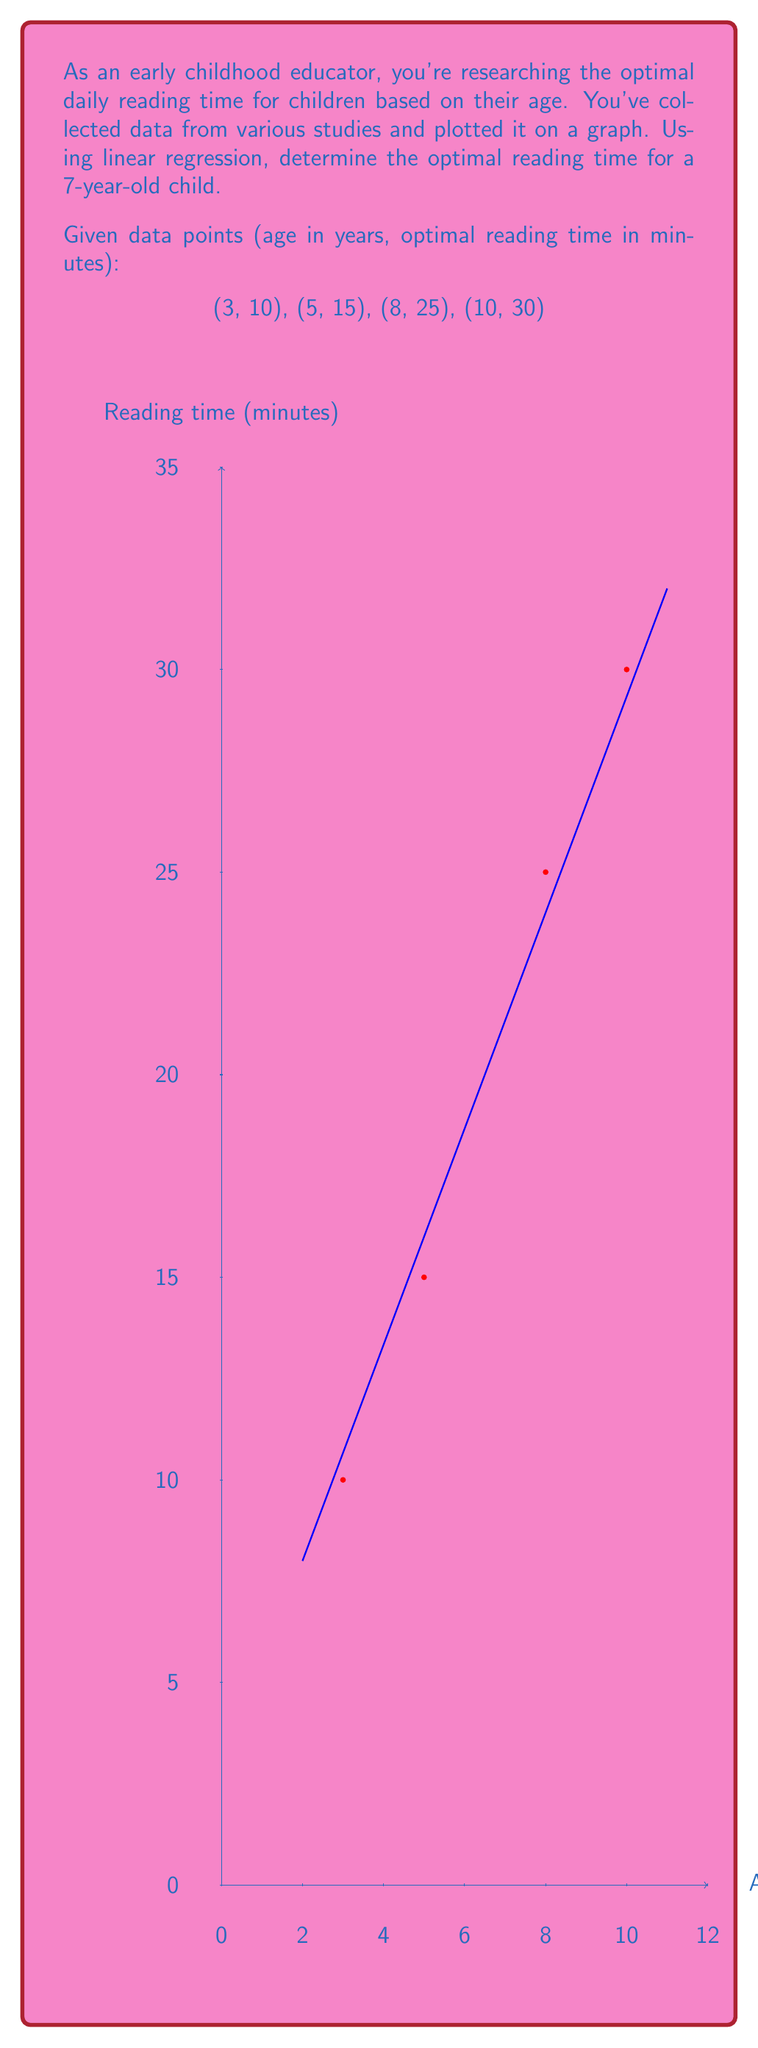Can you solve this math problem? To solve this problem using linear regression, we'll follow these steps:

1) First, we need to find the slope (m) and y-intercept (b) of the linear regression line.

2) The formula for the slope in linear regression is:

   $$m = \frac{n\sum xy - \sum x \sum y}{n\sum x^2 - (\sum x)^2}$$

   where n is the number of data points.

3) Let's calculate the necessary sums:
   $n = 4$
   $\sum x = 3 + 5 + 8 + 10 = 26$
   $\sum y = 10 + 15 + 25 + 30 = 80$
   $\sum xy = 3(10) + 5(15) + 8(25) + 10(30) = 30 + 75 + 200 + 300 = 605$
   $\sum x^2 = 3^2 + 5^2 + 8^2 + 10^2 = 9 + 25 + 64 + 100 = 198$

4) Now we can calculate the slope:

   $$m = \frac{4(605) - 26(80)}{4(198) - 26^2} = \frac{2420 - 2080}{792 - 676} = \frac{340}{116} \approx 2.93$$

5) To find the y-intercept, we use the formula:

   $$b = \frac{\sum y - m\sum x}{n}$$

   $$b = \frac{80 - 2.93(26)}{4} \approx 1.93$$

6) Now we have our linear regression equation:

   $$y = 2.93x + 1.93$$

7) To find the optimal reading time for a 7-year-old, we substitute x = 7:

   $$y = 2.93(7) + 1.93 = 20.51 + 1.93 = 22.44$$

8) Rounding to the nearest minute, the optimal reading time is 22 minutes.
Answer: 22 minutes 